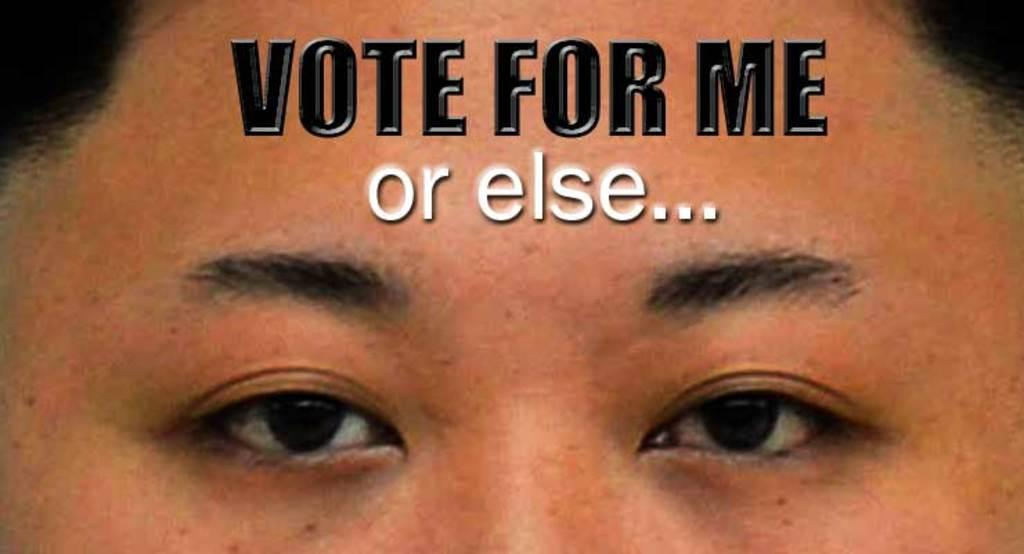What is the main subject of the image? The main subject of the image is a person's face. What else can be seen in the image besides the person's face? There is text in the foreground of the image. How does the person's face contribute to the range of emotions depicted in the image? The image does not depict a range of emotions, as it only shows a person's face and text. 